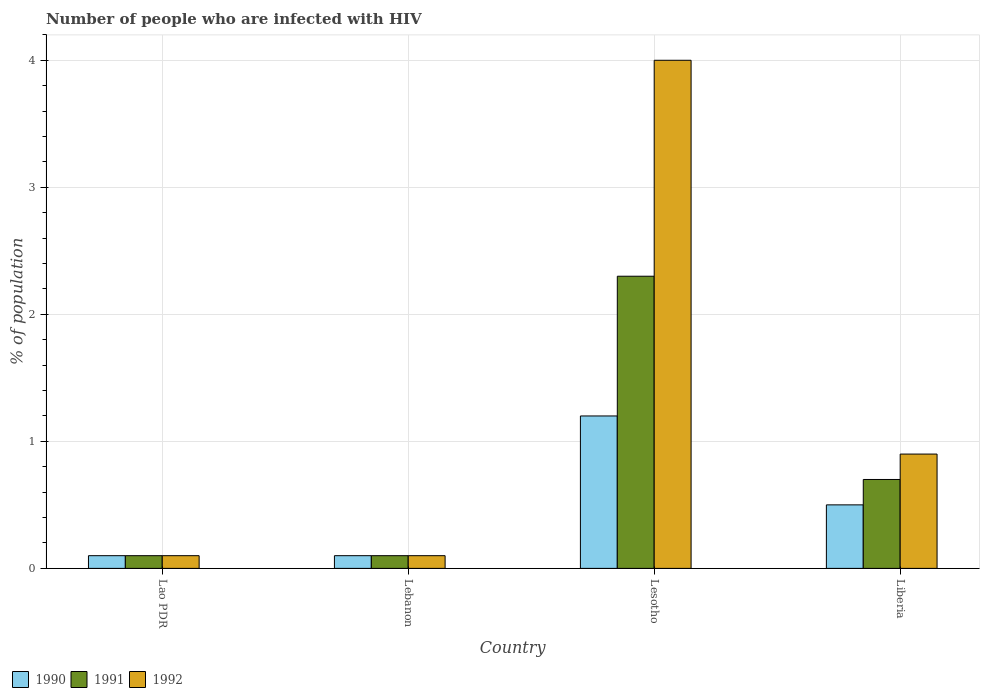How many different coloured bars are there?
Ensure brevity in your answer.  3. Are the number of bars per tick equal to the number of legend labels?
Provide a succinct answer. Yes. Are the number of bars on each tick of the X-axis equal?
Your answer should be compact. Yes. How many bars are there on the 1st tick from the left?
Offer a very short reply. 3. How many bars are there on the 1st tick from the right?
Provide a short and direct response. 3. What is the label of the 1st group of bars from the left?
Keep it short and to the point. Lao PDR. Across all countries, what is the minimum percentage of HIV infected population in in 1992?
Your answer should be compact. 0.1. In which country was the percentage of HIV infected population in in 1992 maximum?
Your answer should be very brief. Lesotho. In which country was the percentage of HIV infected population in in 1990 minimum?
Give a very brief answer. Lao PDR. What is the total percentage of HIV infected population in in 1992 in the graph?
Keep it short and to the point. 5.1. What is the difference between the percentage of HIV infected population in in 1990 in Lao PDR and that in Liberia?
Provide a succinct answer. -0.4. What is the difference between the percentage of HIV infected population in in 1991 in Lebanon and the percentage of HIV infected population in in 1990 in Liberia?
Keep it short and to the point. -0.4. What is the average percentage of HIV infected population in in 1992 per country?
Your answer should be very brief. 1.28. In how many countries, is the percentage of HIV infected population in in 1990 greater than 4 %?
Give a very brief answer. 0. Is the percentage of HIV infected population in in 1990 in Lesotho less than that in Liberia?
Provide a short and direct response. No. What is the difference between the highest and the lowest percentage of HIV infected population in in 1991?
Make the answer very short. 2.2. Is the sum of the percentage of HIV infected population in in 1991 in Lao PDR and Liberia greater than the maximum percentage of HIV infected population in in 1990 across all countries?
Offer a terse response. No. What does the 1st bar from the left in Lesotho represents?
Provide a succinct answer. 1990. What does the 1st bar from the right in Lesotho represents?
Provide a short and direct response. 1992. Is it the case that in every country, the sum of the percentage of HIV infected population in in 1991 and percentage of HIV infected population in in 1990 is greater than the percentage of HIV infected population in in 1992?
Give a very brief answer. No. How many bars are there?
Ensure brevity in your answer.  12. How many countries are there in the graph?
Your response must be concise. 4. What is the difference between two consecutive major ticks on the Y-axis?
Your answer should be very brief. 1. Does the graph contain any zero values?
Your answer should be very brief. No. How are the legend labels stacked?
Your response must be concise. Horizontal. What is the title of the graph?
Ensure brevity in your answer.  Number of people who are infected with HIV. Does "1973" appear as one of the legend labels in the graph?
Give a very brief answer. No. What is the label or title of the X-axis?
Your response must be concise. Country. What is the label or title of the Y-axis?
Make the answer very short. % of population. What is the % of population of 1992 in Lao PDR?
Offer a terse response. 0.1. What is the % of population of 1990 in Lebanon?
Keep it short and to the point. 0.1. What is the % of population of 1991 in Lebanon?
Your answer should be compact. 0.1. What is the % of population in 1992 in Lebanon?
Give a very brief answer. 0.1. What is the % of population in 1991 in Lesotho?
Your response must be concise. 2.3. What is the % of population in 1992 in Lesotho?
Your response must be concise. 4. What is the % of population in 1990 in Liberia?
Your response must be concise. 0.5. Across all countries, what is the maximum % of population of 1991?
Provide a succinct answer. 2.3. Across all countries, what is the minimum % of population of 1990?
Make the answer very short. 0.1. Across all countries, what is the minimum % of population in 1991?
Your response must be concise. 0.1. Across all countries, what is the minimum % of population of 1992?
Provide a short and direct response. 0.1. What is the total % of population of 1990 in the graph?
Your answer should be very brief. 1.9. What is the total % of population of 1992 in the graph?
Give a very brief answer. 5.1. What is the difference between the % of population of 1992 in Lao PDR and that in Lebanon?
Keep it short and to the point. 0. What is the difference between the % of population of 1990 in Lao PDR and that in Lesotho?
Offer a very short reply. -1.1. What is the difference between the % of population of 1991 in Lao PDR and that in Lesotho?
Your answer should be very brief. -2.2. What is the difference between the % of population in 1992 in Lao PDR and that in Lesotho?
Your answer should be very brief. -3.9. What is the difference between the % of population of 1991 in Lao PDR and that in Liberia?
Your answer should be compact. -0.6. What is the difference between the % of population in 1992 in Lao PDR and that in Liberia?
Offer a terse response. -0.8. What is the difference between the % of population in 1990 in Lebanon and that in Lesotho?
Your answer should be compact. -1.1. What is the difference between the % of population of 1990 in Lesotho and that in Liberia?
Your answer should be compact. 0.7. What is the difference between the % of population in 1991 in Lesotho and that in Liberia?
Provide a succinct answer. 1.6. What is the difference between the % of population of 1990 in Lao PDR and the % of population of 1991 in Lebanon?
Keep it short and to the point. 0. What is the difference between the % of population in 1990 in Lao PDR and the % of population in 1992 in Lebanon?
Ensure brevity in your answer.  0. What is the difference between the % of population of 1990 in Lao PDR and the % of population of 1992 in Lesotho?
Your answer should be compact. -3.9. What is the difference between the % of population of 1990 in Lao PDR and the % of population of 1991 in Liberia?
Provide a short and direct response. -0.6. What is the difference between the % of population of 1991 in Lebanon and the % of population of 1992 in Lesotho?
Your answer should be compact. -3.9. What is the difference between the % of population in 1990 in Lebanon and the % of population in 1991 in Liberia?
Your answer should be compact. -0.6. What is the difference between the % of population in 1991 in Lebanon and the % of population in 1992 in Liberia?
Provide a short and direct response. -0.8. What is the average % of population in 1990 per country?
Offer a very short reply. 0.47. What is the average % of population in 1991 per country?
Offer a terse response. 0.8. What is the average % of population in 1992 per country?
Ensure brevity in your answer.  1.27. What is the difference between the % of population in 1990 and % of population in 1991 in Lao PDR?
Your answer should be very brief. 0. What is the difference between the % of population in 1990 and % of population in 1991 in Lebanon?
Provide a short and direct response. 0. What is the difference between the % of population of 1990 and % of population of 1992 in Lebanon?
Your response must be concise. 0. What is the difference between the % of population of 1991 and % of population of 1992 in Liberia?
Your answer should be compact. -0.2. What is the ratio of the % of population in 1990 in Lao PDR to that in Lebanon?
Offer a terse response. 1. What is the ratio of the % of population in 1990 in Lao PDR to that in Lesotho?
Provide a short and direct response. 0.08. What is the ratio of the % of population of 1991 in Lao PDR to that in Lesotho?
Your response must be concise. 0.04. What is the ratio of the % of population in 1992 in Lao PDR to that in Lesotho?
Offer a very short reply. 0.03. What is the ratio of the % of population of 1990 in Lao PDR to that in Liberia?
Offer a very short reply. 0.2. What is the ratio of the % of population of 1991 in Lao PDR to that in Liberia?
Provide a short and direct response. 0.14. What is the ratio of the % of population in 1992 in Lao PDR to that in Liberia?
Your response must be concise. 0.11. What is the ratio of the % of population in 1990 in Lebanon to that in Lesotho?
Your response must be concise. 0.08. What is the ratio of the % of population in 1991 in Lebanon to that in Lesotho?
Ensure brevity in your answer.  0.04. What is the ratio of the % of population in 1992 in Lebanon to that in Lesotho?
Offer a very short reply. 0.03. What is the ratio of the % of population in 1990 in Lebanon to that in Liberia?
Your response must be concise. 0.2. What is the ratio of the % of population of 1991 in Lebanon to that in Liberia?
Make the answer very short. 0.14. What is the ratio of the % of population of 1991 in Lesotho to that in Liberia?
Provide a succinct answer. 3.29. What is the ratio of the % of population of 1992 in Lesotho to that in Liberia?
Offer a terse response. 4.44. What is the difference between the highest and the second highest % of population of 1990?
Your answer should be very brief. 0.7. What is the difference between the highest and the second highest % of population in 1992?
Keep it short and to the point. 3.1. 